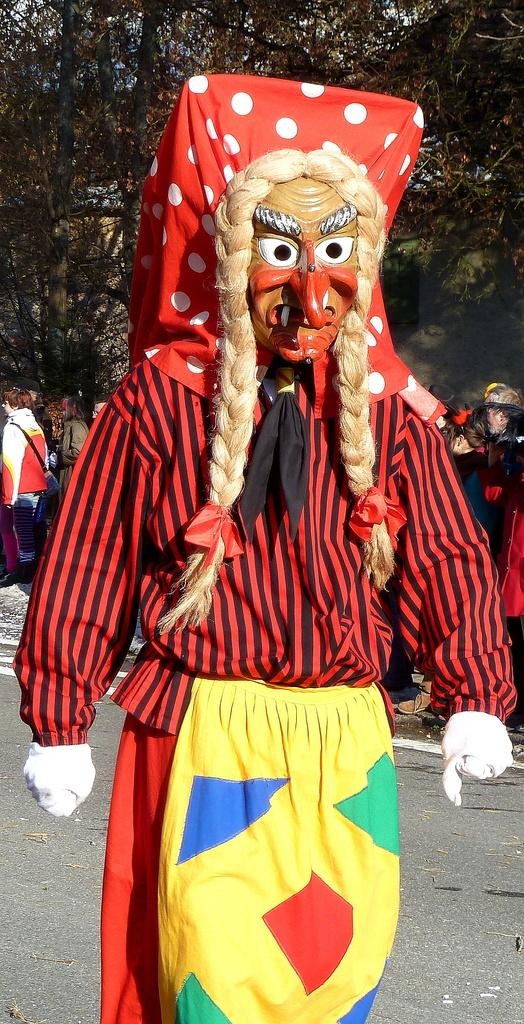What is the person in the image wearing? The person is wearing a costume in the image. What is the person in the costume doing? The person is walking. Can you describe the background of the image? There are persons and trees in the background of the image. What type of fruit is the person holding in the image? There is no fruit present in the image; the person is wearing a costume and walking. 